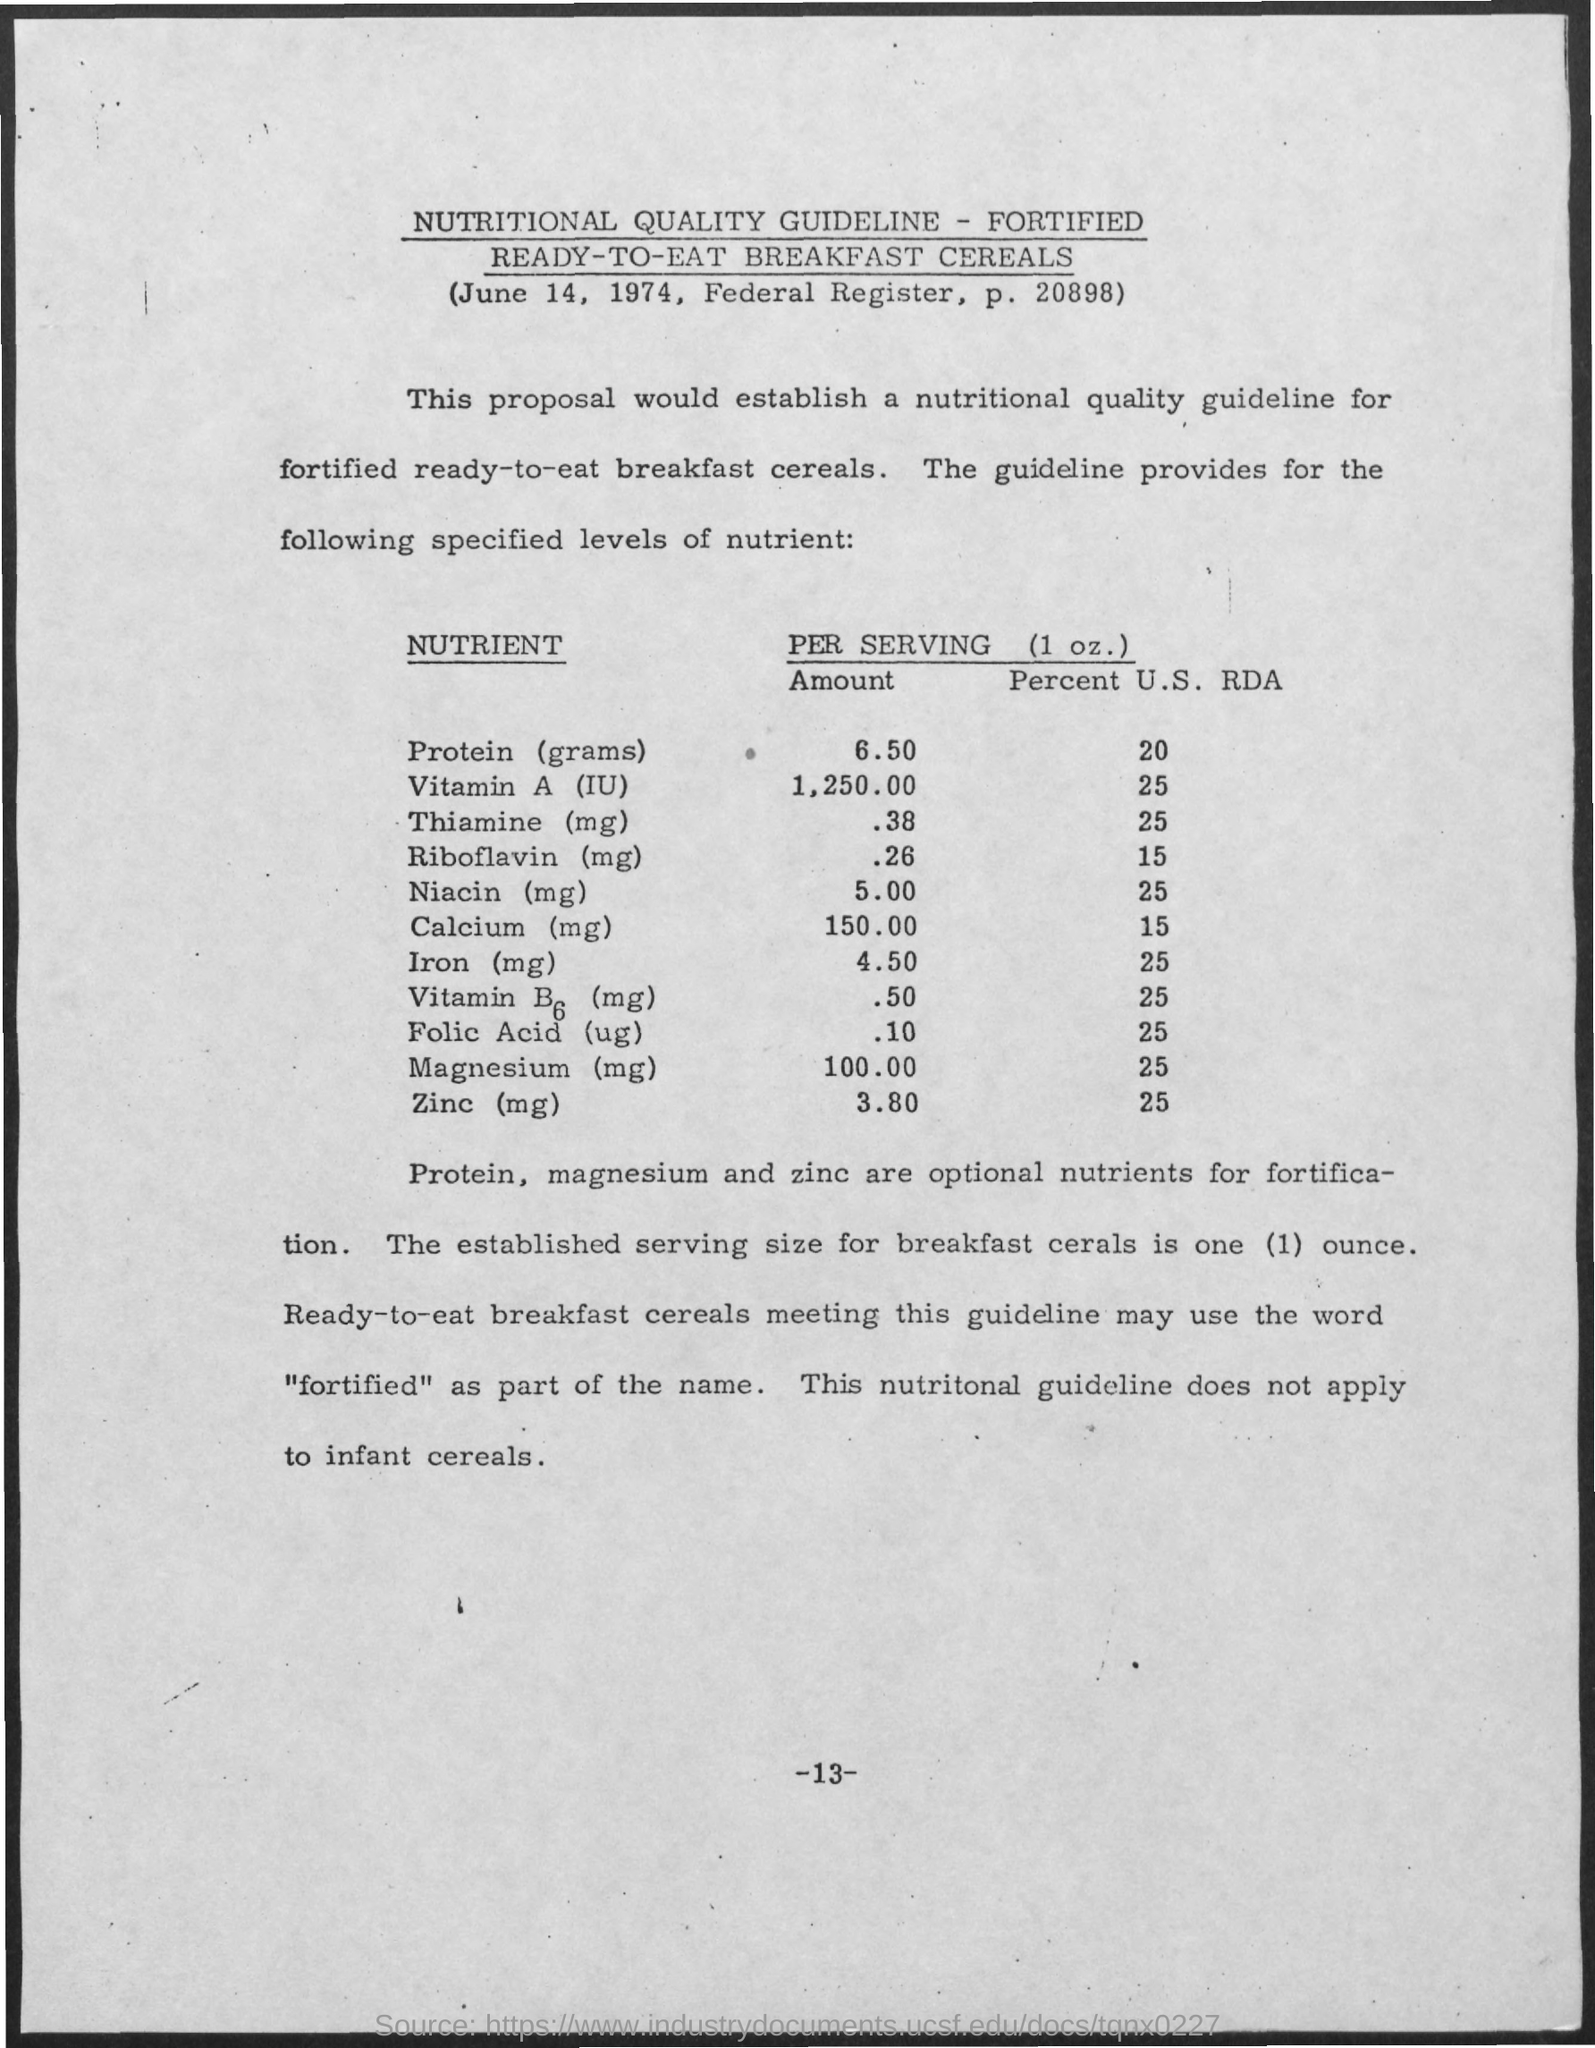What are optional nutrients for fortification?
Make the answer very short. Protein, magnesium and zinc. 